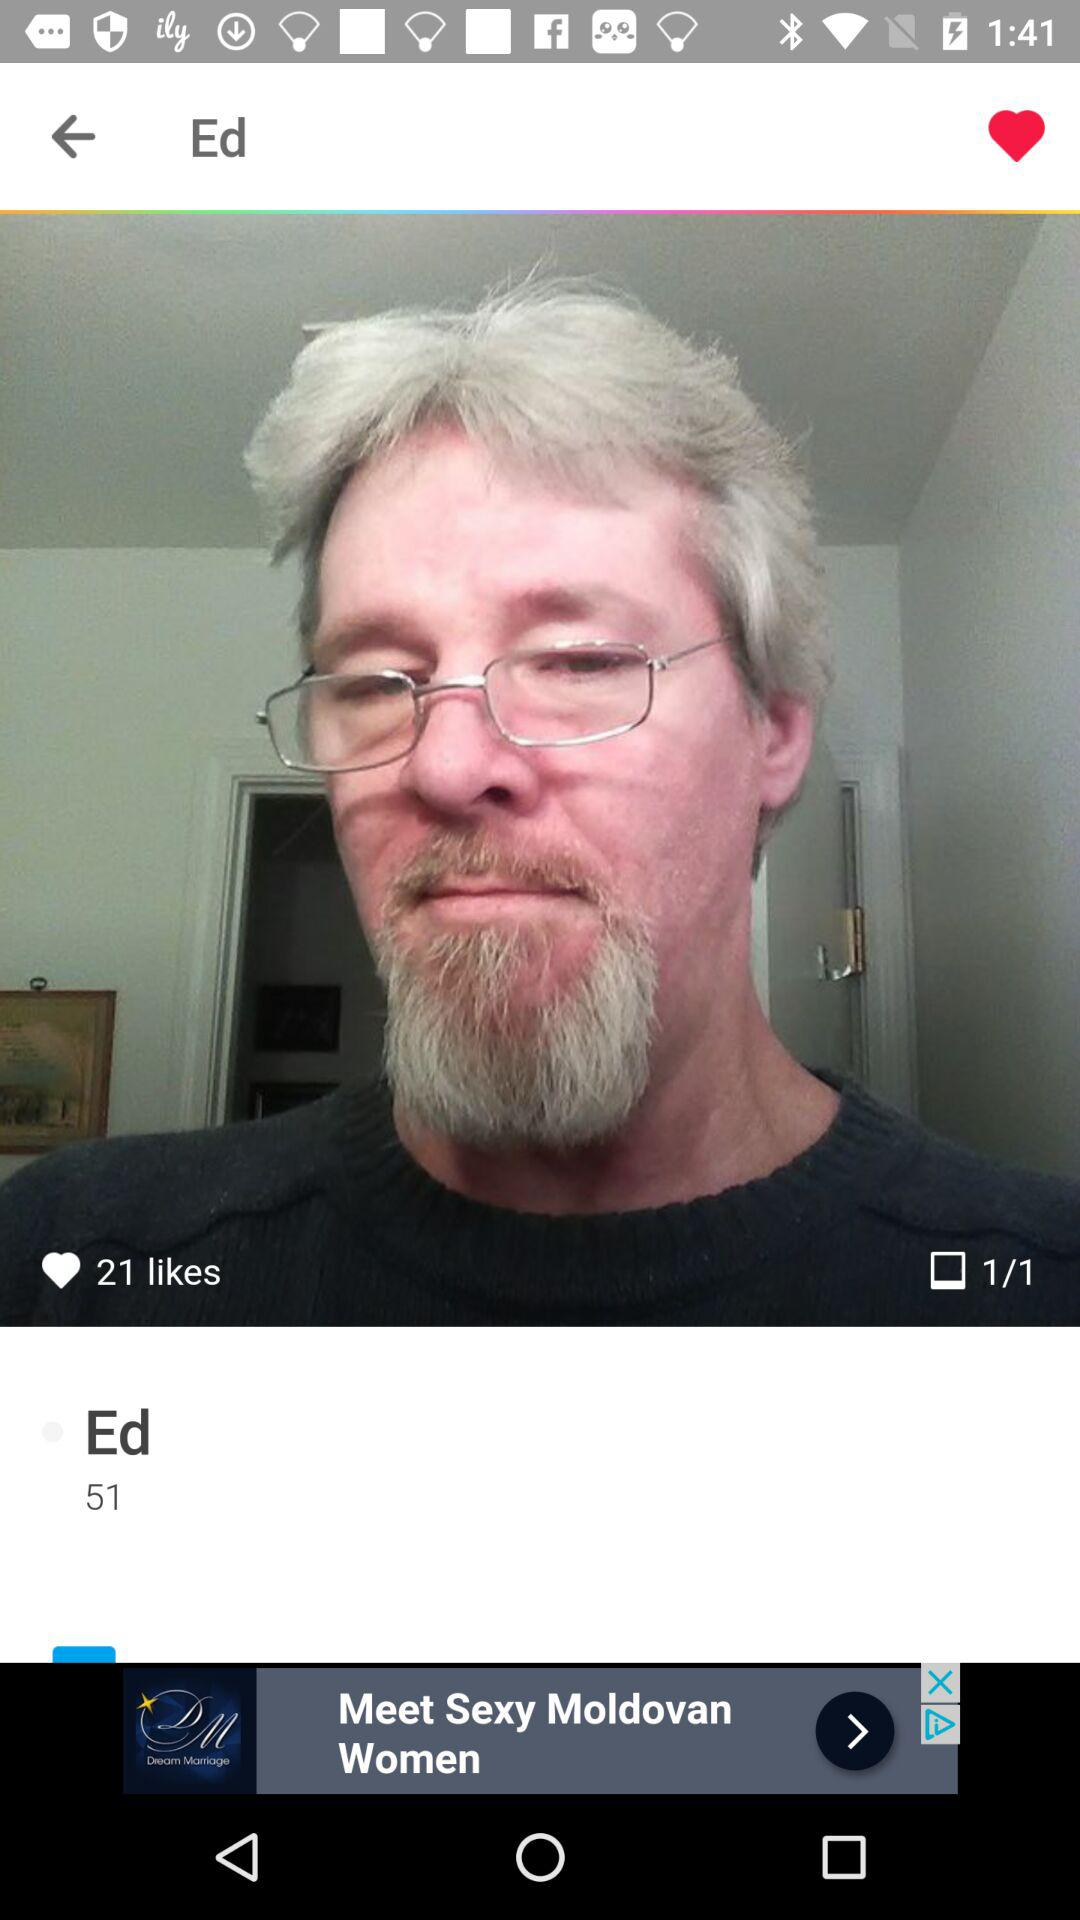How many photos are there in total? There is only 1 photo. 